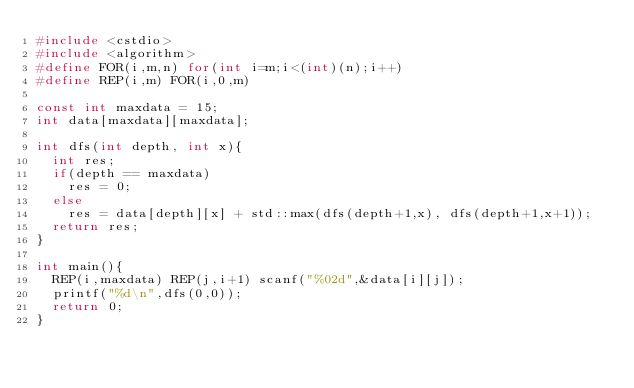<code> <loc_0><loc_0><loc_500><loc_500><_C++_>#include <cstdio>
#include <algorithm>
#define FOR(i,m,n) for(int i=m;i<(int)(n);i++)
#define REP(i,m) FOR(i,0,m)

const int maxdata = 15;
int data[maxdata][maxdata];

int dfs(int depth, int x){
  int res;
  if(depth == maxdata)
    res = 0;
  else
    res = data[depth][x] + std::max(dfs(depth+1,x), dfs(depth+1,x+1));
  return res;
}

int main(){
  REP(i,maxdata) REP(j,i+1) scanf("%02d",&data[i][j]);
  printf("%d\n",dfs(0,0));
  return 0;
}
</code> 